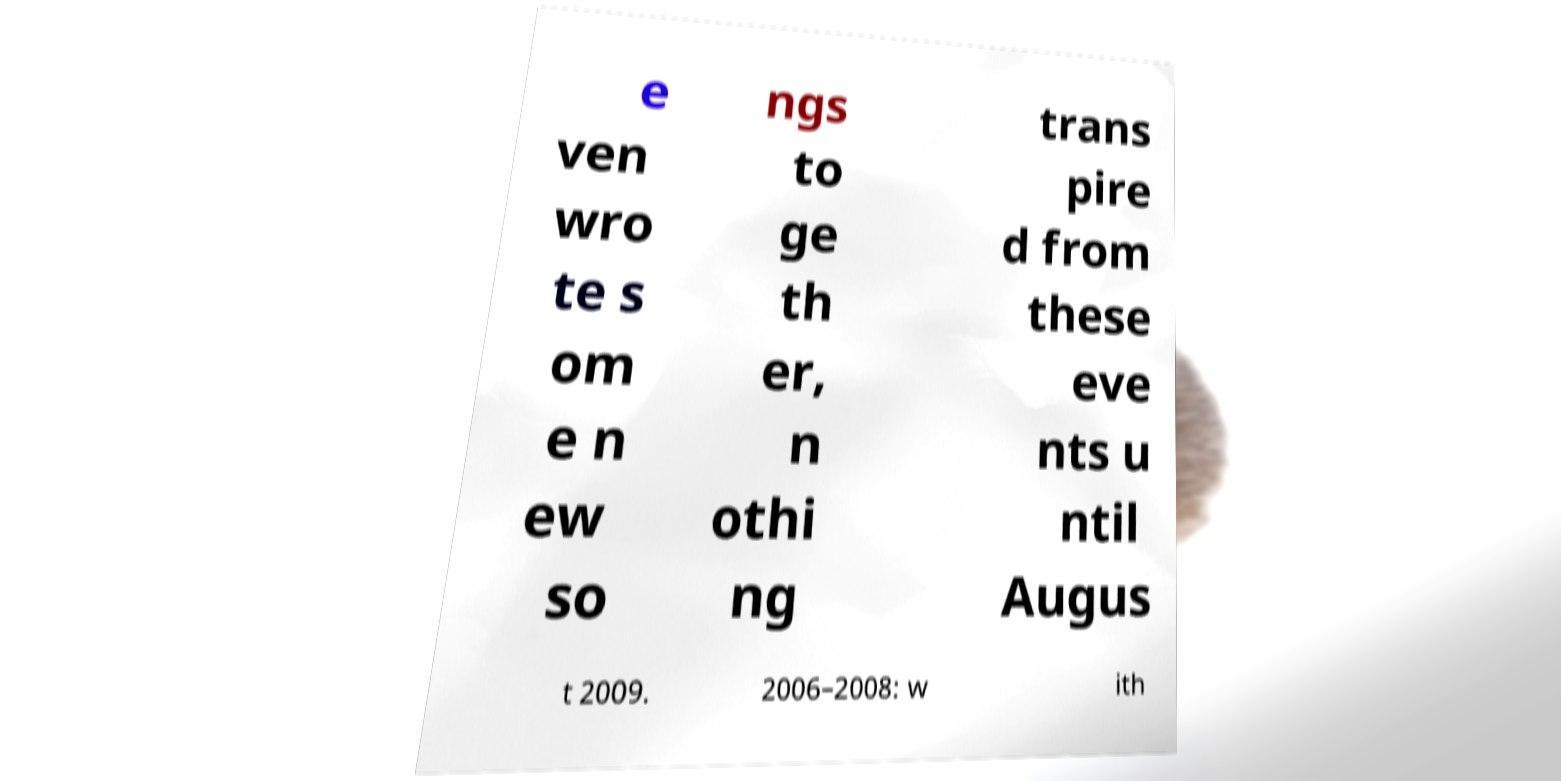Can you read and provide the text displayed in the image?This photo seems to have some interesting text. Can you extract and type it out for me? e ven wro te s om e n ew so ngs to ge th er, n othi ng trans pire d from these eve nts u ntil Augus t 2009. 2006–2008: w ith 